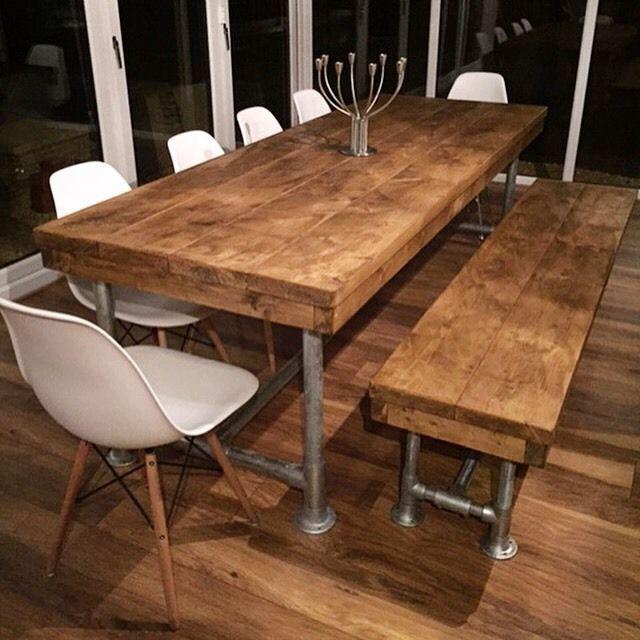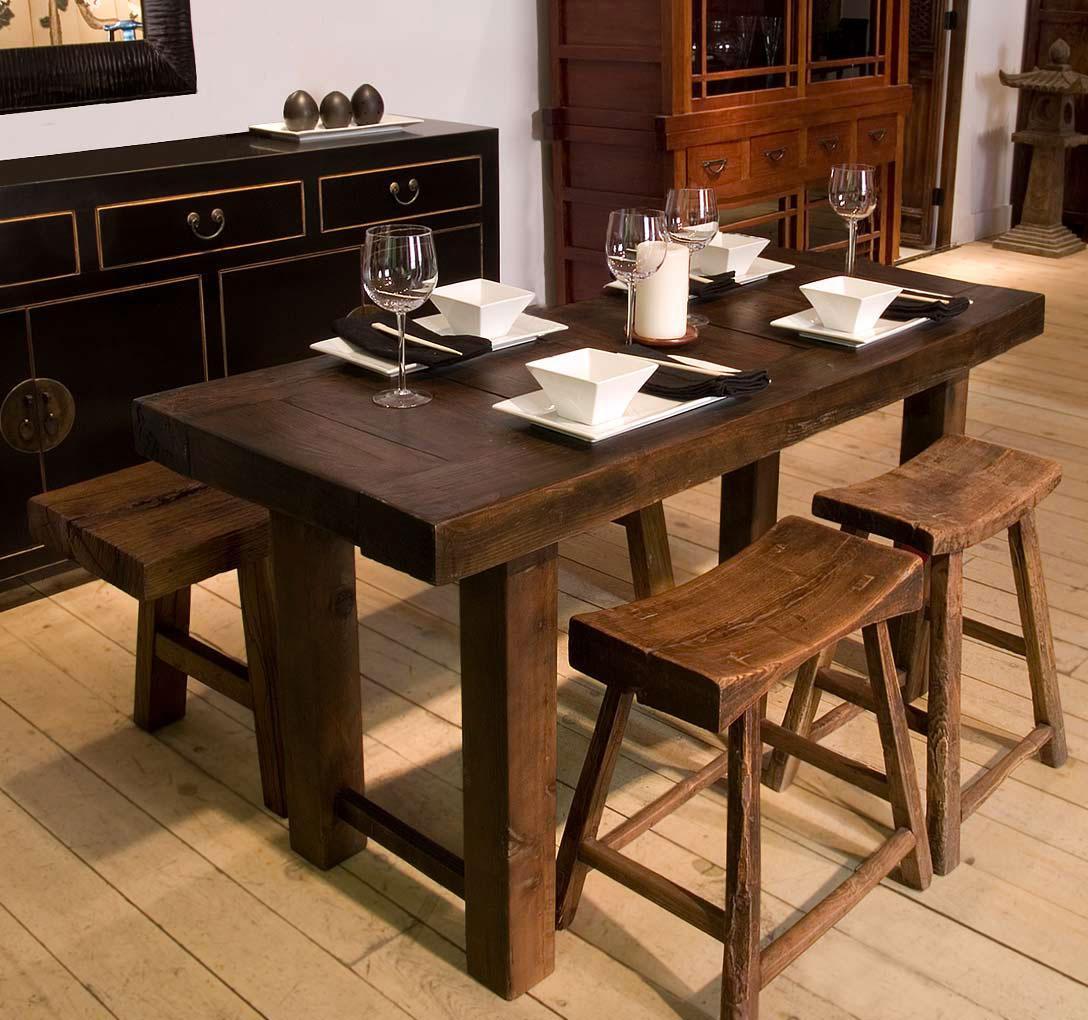The first image is the image on the left, the second image is the image on the right. Evaluate the accuracy of this statement regarding the images: "There is a vase with flowers in the image on the left.". Is it true? Answer yes or no. No. 